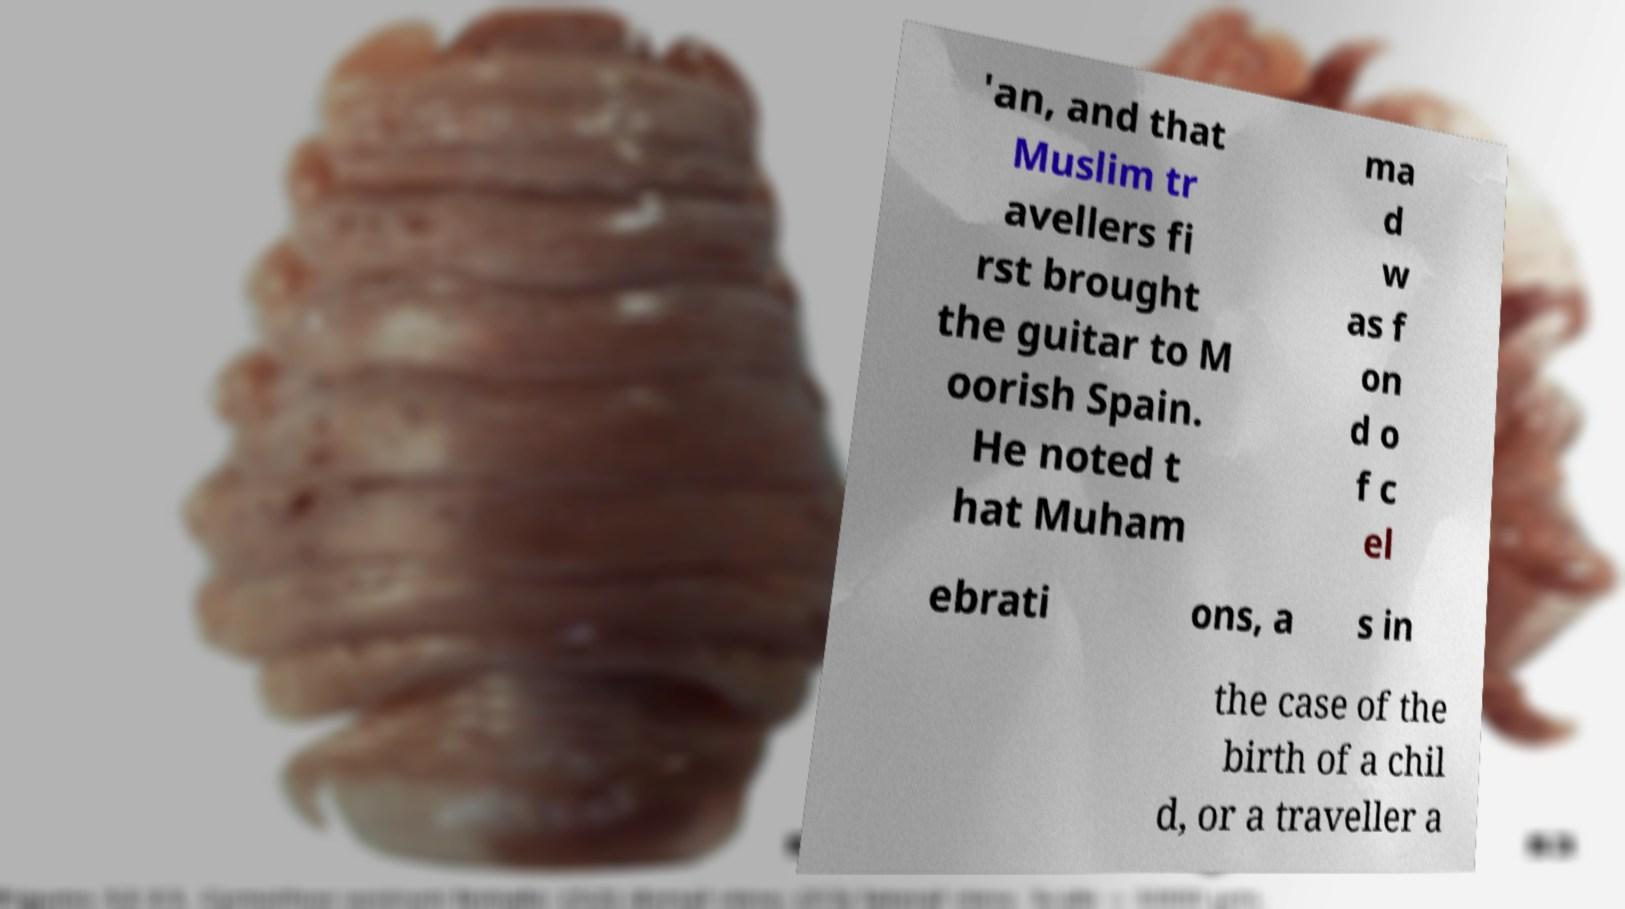I need the written content from this picture converted into text. Can you do that? 'an, and that Muslim tr avellers fi rst brought the guitar to M oorish Spain. He noted t hat Muham ma d w as f on d o f c el ebrati ons, a s in the case of the birth of a chil d, or a traveller a 